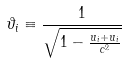Convert formula to latex. <formula><loc_0><loc_0><loc_500><loc_500>\vartheta _ { i } \equiv \frac { 1 } { \sqrt { 1 - \frac { u _ { i } + u _ { i } } { c ^ { 2 } } } }</formula> 